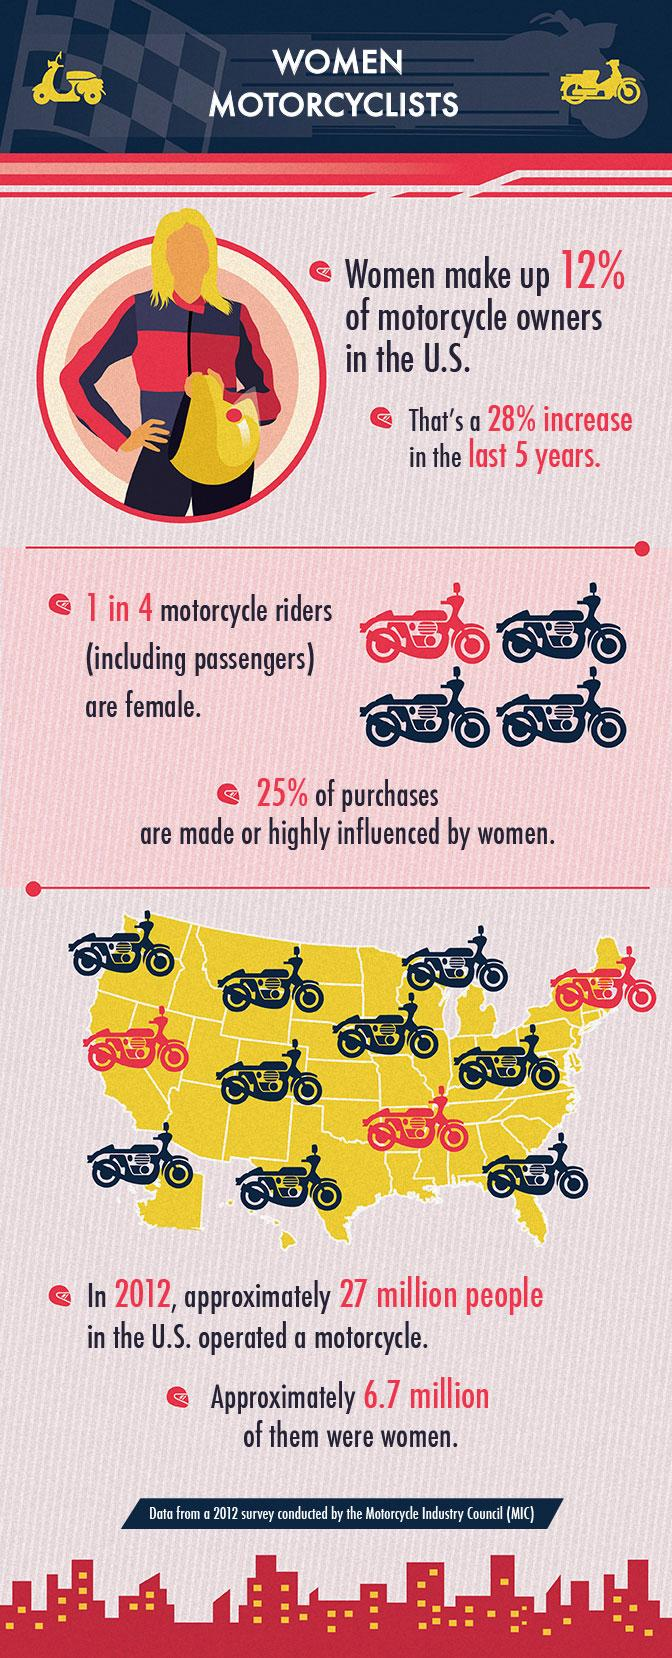Indicate a few pertinent items in this graphic. According to a recent survey, it was found that 88% of motorcycle owners in the United States are not women. Out of 4 motorcycle riders, 3 are not female. It is estimated that over three-quarters of purchases are not made by women. 